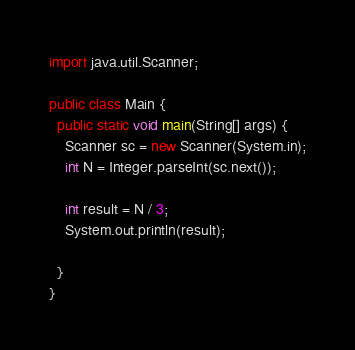<code> <loc_0><loc_0><loc_500><loc_500><_Java_>import java.util.Scanner;

public class Main {
  public static void main(String[] args) {
    Scanner sc = new Scanner(System.in);
    int N = Integer.parseInt(sc.next());

    int result = N / 3;
    System.out.println(result);

  }
}
</code> 